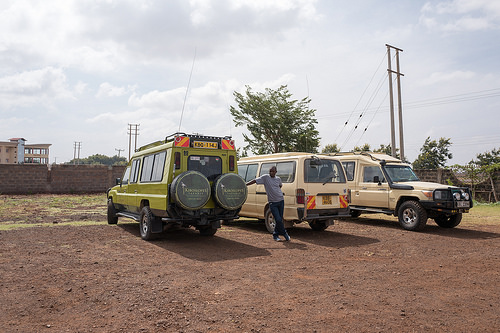<image>
Can you confirm if the man is on the car? Yes. Looking at the image, I can see the man is positioned on top of the car, with the car providing support. 